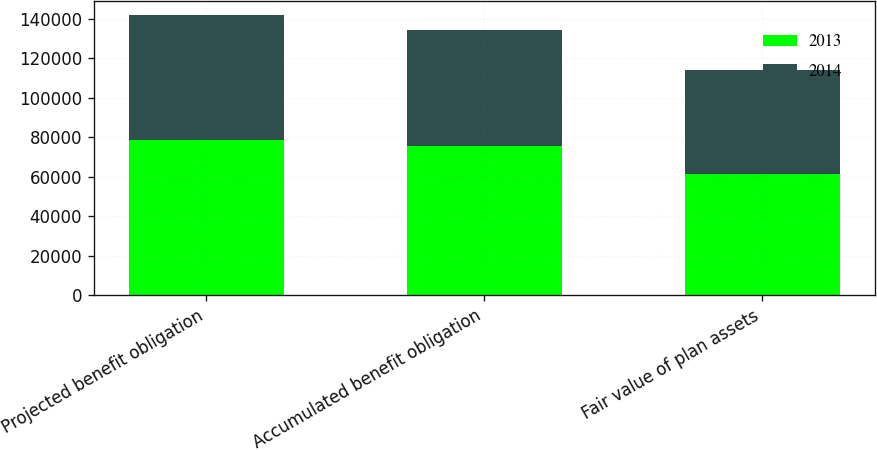Convert chart to OTSL. <chart><loc_0><loc_0><loc_500><loc_500><stacked_bar_chart><ecel><fcel>Projected benefit obligation<fcel>Accumulated benefit obligation<fcel>Fair value of plan assets<nl><fcel>2013<fcel>78358<fcel>75622<fcel>61082<nl><fcel>2014<fcel>63445<fcel>58334<fcel>52905<nl></chart> 